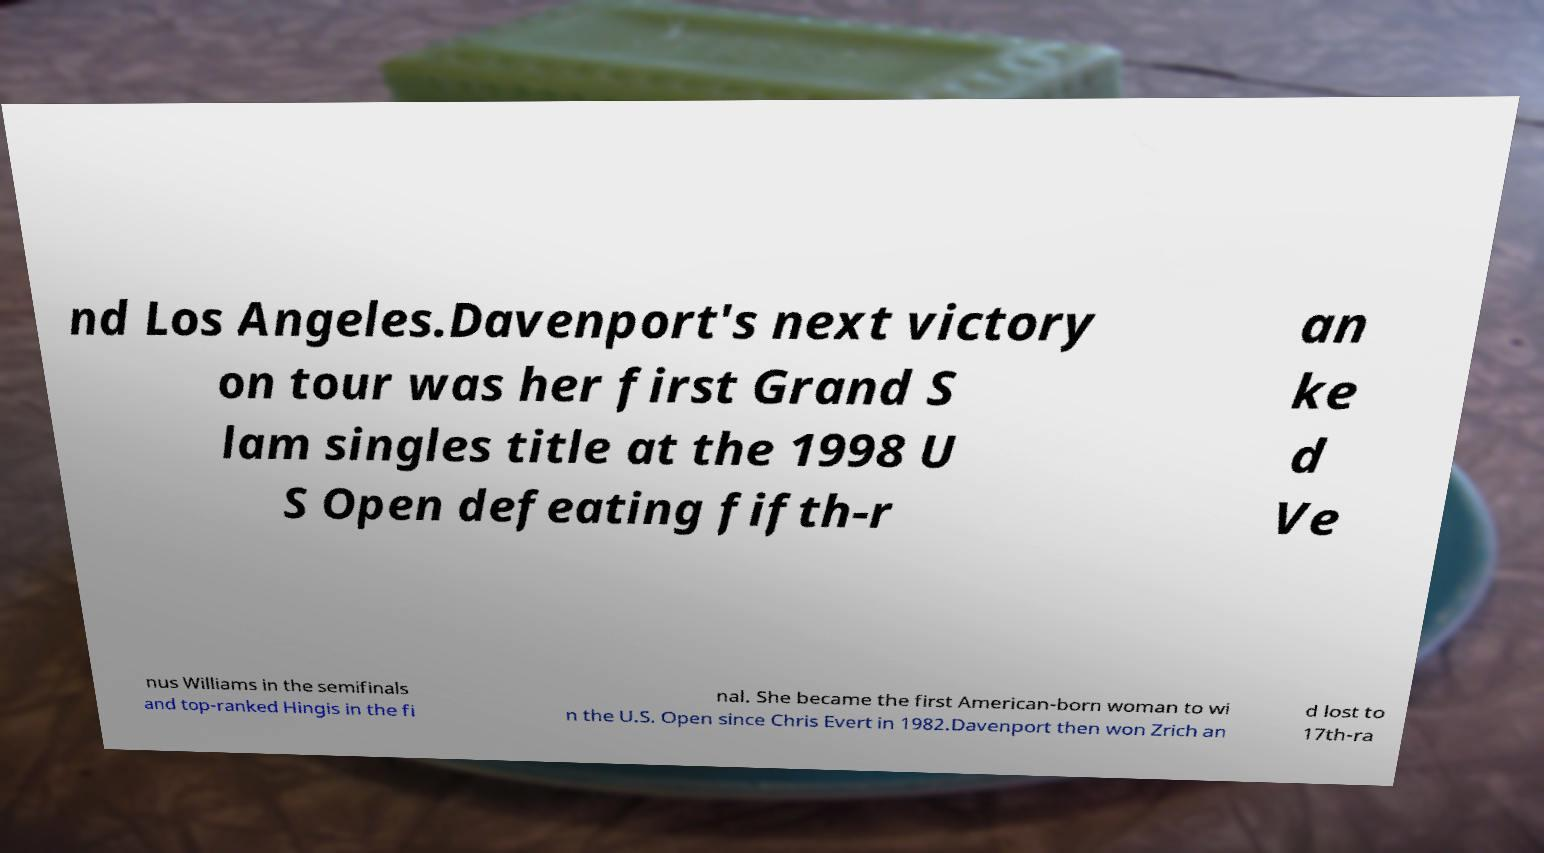For documentation purposes, I need the text within this image transcribed. Could you provide that? nd Los Angeles.Davenport's next victory on tour was her first Grand S lam singles title at the 1998 U S Open defeating fifth-r an ke d Ve nus Williams in the semifinals and top-ranked Hingis in the fi nal. She became the first American-born woman to wi n the U.S. Open since Chris Evert in 1982.Davenport then won Zrich an d lost to 17th-ra 